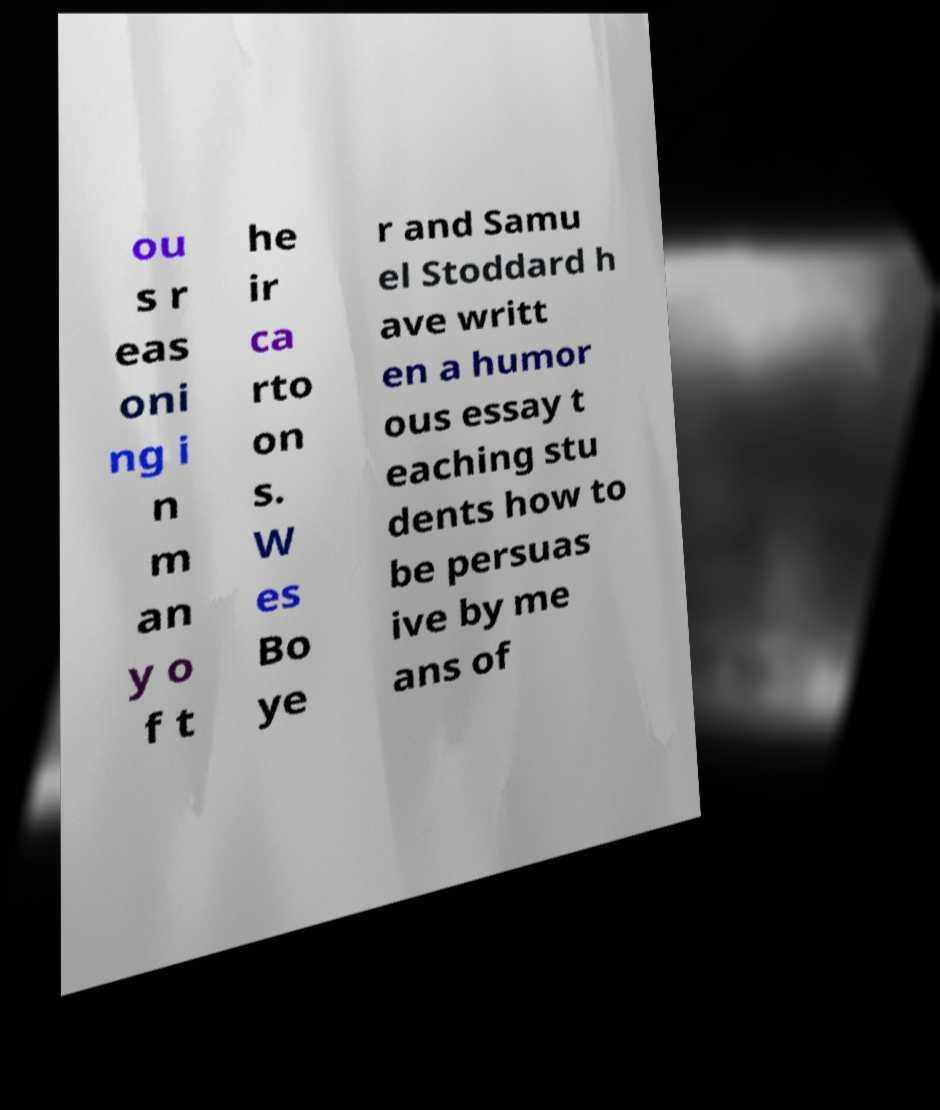For documentation purposes, I need the text within this image transcribed. Could you provide that? ou s r eas oni ng i n m an y o f t he ir ca rto on s. W es Bo ye r and Samu el Stoddard h ave writt en a humor ous essay t eaching stu dents how to be persuas ive by me ans of 